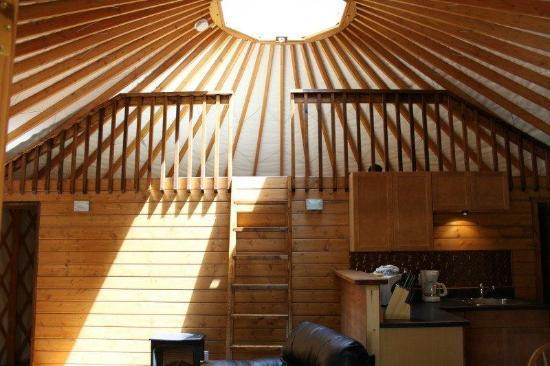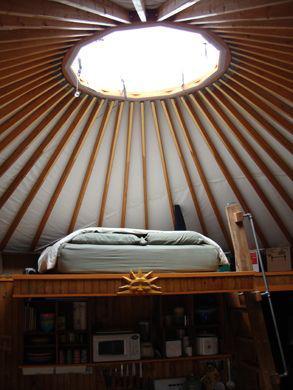The first image is the image on the left, the second image is the image on the right. Evaluate the accuracy of this statement regarding the images: "Left image shows a camera-facing ladder in front of a loft area with a railing of vertical posts.". Is it true? Answer yes or no. Yes. The first image is the image on the left, the second image is the image on the right. Assess this claim about the two images: "A painting hangs on the wall in the image on the right.". Correct or not? Answer yes or no. No. 